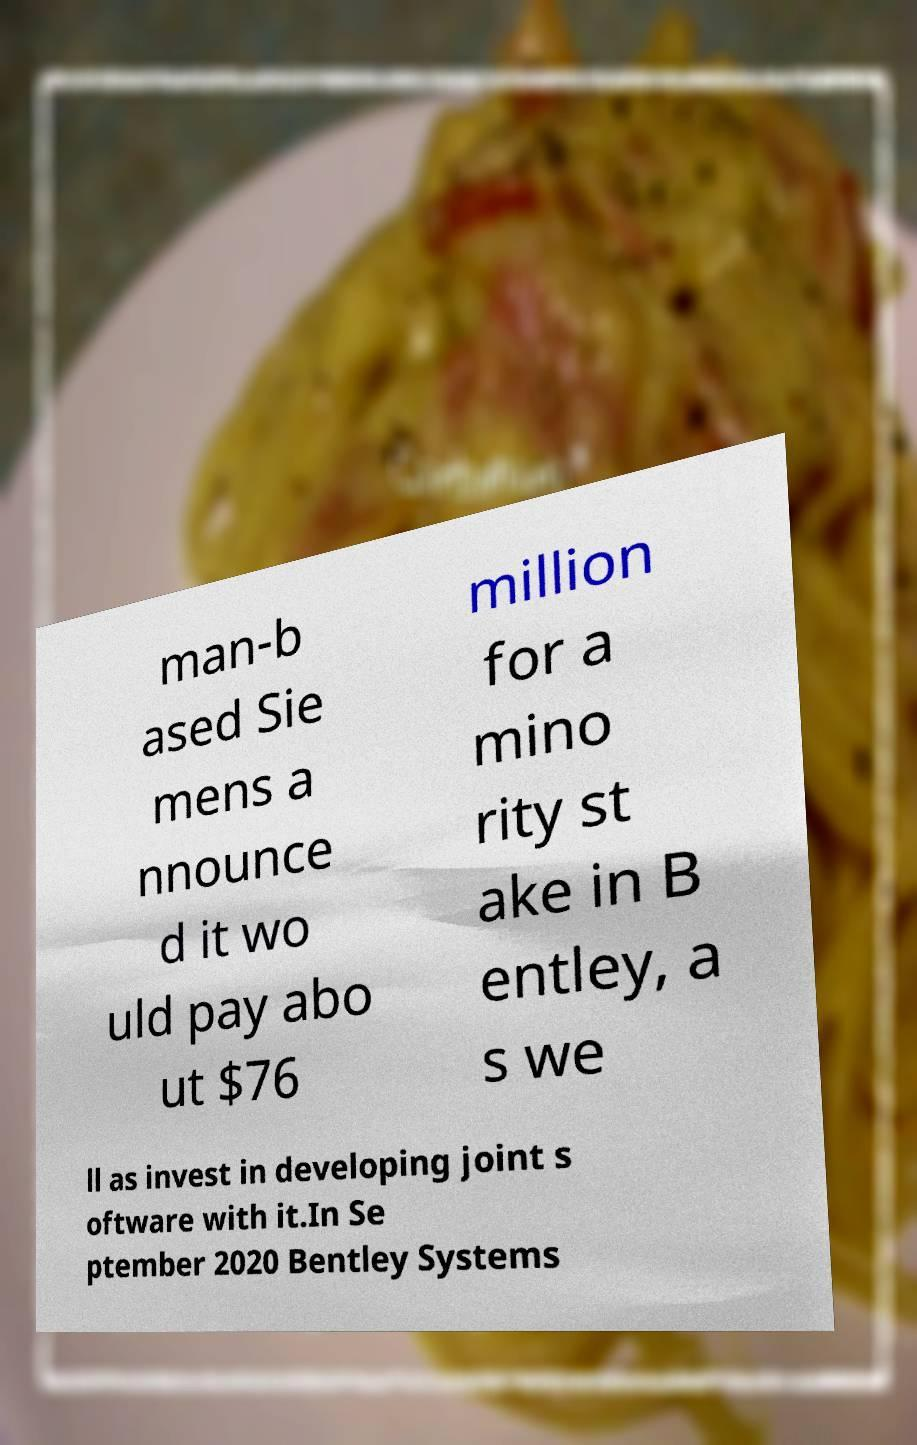There's text embedded in this image that I need extracted. Can you transcribe it verbatim? man-b ased Sie mens a nnounce d it wo uld pay abo ut $76 million for a mino rity st ake in B entley, a s we ll as invest in developing joint s oftware with it.In Se ptember 2020 Bentley Systems 